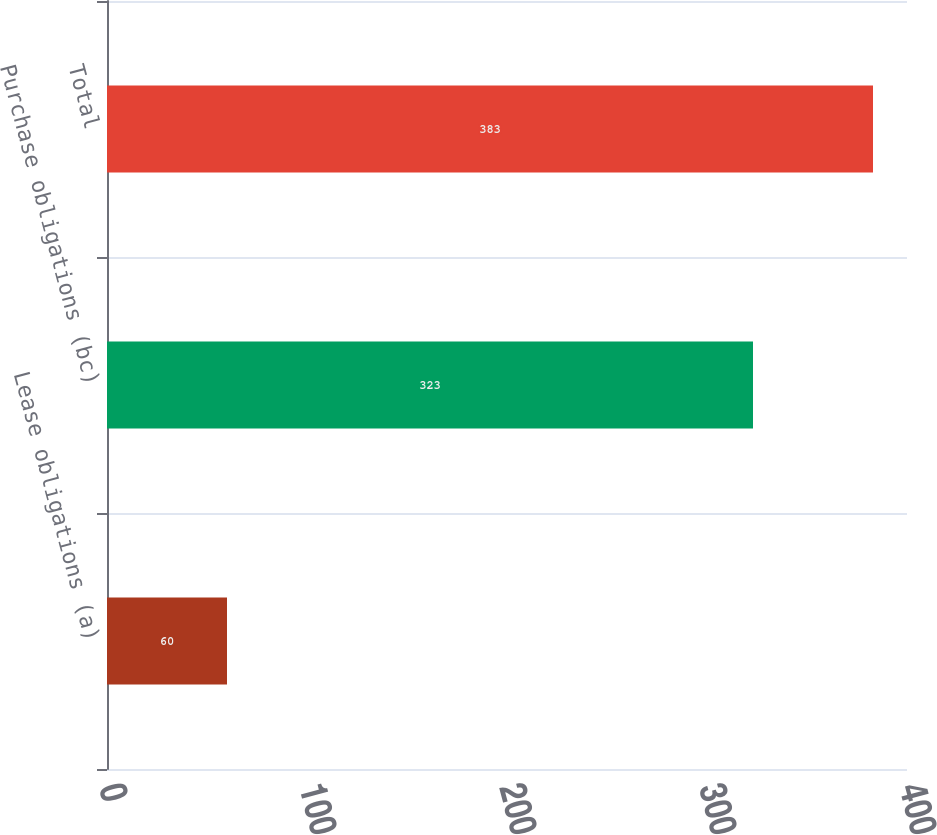Convert chart to OTSL. <chart><loc_0><loc_0><loc_500><loc_500><bar_chart><fcel>Lease obligations (a)<fcel>Purchase obligations (bc)<fcel>Total<nl><fcel>60<fcel>323<fcel>383<nl></chart> 